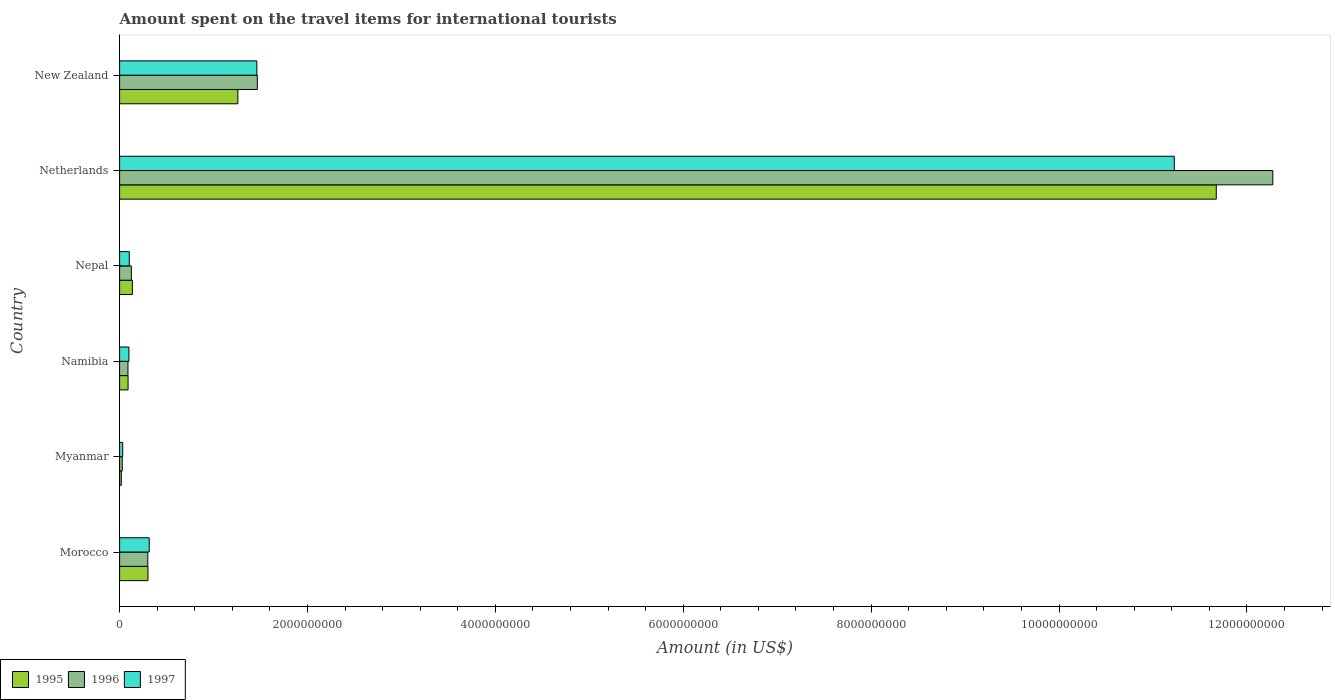How many groups of bars are there?
Provide a short and direct response. 6. Are the number of bars on each tick of the Y-axis equal?
Offer a very short reply. Yes. How many bars are there on the 5th tick from the top?
Your response must be concise. 3. What is the label of the 2nd group of bars from the top?
Ensure brevity in your answer.  Netherlands. In how many cases, is the number of bars for a given country not equal to the number of legend labels?
Ensure brevity in your answer.  0. What is the amount spent on the travel items for international tourists in 1995 in Namibia?
Make the answer very short. 9.00e+07. Across all countries, what is the maximum amount spent on the travel items for international tourists in 1996?
Provide a short and direct response. 1.23e+1. Across all countries, what is the minimum amount spent on the travel items for international tourists in 1997?
Offer a terse response. 3.30e+07. In which country was the amount spent on the travel items for international tourists in 1996 maximum?
Ensure brevity in your answer.  Netherlands. In which country was the amount spent on the travel items for international tourists in 1996 minimum?
Your answer should be very brief. Myanmar. What is the total amount spent on the travel items for international tourists in 1996 in the graph?
Keep it short and to the point. 1.43e+1. What is the difference between the amount spent on the travel items for international tourists in 1996 in Myanmar and that in Nepal?
Provide a succinct answer. -9.70e+07. What is the difference between the amount spent on the travel items for international tourists in 1995 in Myanmar and the amount spent on the travel items for international tourists in 1996 in Morocco?
Keep it short and to the point. -2.82e+08. What is the average amount spent on the travel items for international tourists in 1997 per country?
Provide a short and direct response. 2.21e+09. What is the difference between the amount spent on the travel items for international tourists in 1996 and amount spent on the travel items for international tourists in 1997 in Nepal?
Offer a very short reply. 2.20e+07. In how many countries, is the amount spent on the travel items for international tourists in 1996 greater than 6000000000 US$?
Keep it short and to the point. 1. What is the ratio of the amount spent on the travel items for international tourists in 1996 in Nepal to that in Netherlands?
Your answer should be compact. 0.01. Is the amount spent on the travel items for international tourists in 1995 in Morocco less than that in New Zealand?
Offer a very short reply. Yes. Is the difference between the amount spent on the travel items for international tourists in 1996 in Morocco and Netherlands greater than the difference between the amount spent on the travel items for international tourists in 1997 in Morocco and Netherlands?
Provide a short and direct response. No. What is the difference between the highest and the second highest amount spent on the travel items for international tourists in 1995?
Offer a terse response. 1.04e+1. What is the difference between the highest and the lowest amount spent on the travel items for international tourists in 1996?
Provide a succinct answer. 1.22e+1. Is the sum of the amount spent on the travel items for international tourists in 1995 in Morocco and Nepal greater than the maximum amount spent on the travel items for international tourists in 1996 across all countries?
Your answer should be very brief. No. What does the 2nd bar from the bottom in Netherlands represents?
Your answer should be compact. 1996. Is it the case that in every country, the sum of the amount spent on the travel items for international tourists in 1995 and amount spent on the travel items for international tourists in 1997 is greater than the amount spent on the travel items for international tourists in 1996?
Keep it short and to the point. Yes. How many bars are there?
Offer a very short reply. 18. What is the difference between two consecutive major ticks on the X-axis?
Make the answer very short. 2.00e+09. Are the values on the major ticks of X-axis written in scientific E-notation?
Provide a short and direct response. No. Does the graph contain any zero values?
Your response must be concise. No. How are the legend labels stacked?
Provide a short and direct response. Horizontal. What is the title of the graph?
Make the answer very short. Amount spent on the travel items for international tourists. Does "1982" appear as one of the legend labels in the graph?
Provide a succinct answer. No. What is the label or title of the X-axis?
Provide a short and direct response. Amount (in US$). What is the Amount (in US$) of 1995 in Morocco?
Your answer should be very brief. 3.02e+08. What is the Amount (in US$) of 1996 in Morocco?
Keep it short and to the point. 3.00e+08. What is the Amount (in US$) of 1997 in Morocco?
Make the answer very short. 3.15e+08. What is the Amount (in US$) in 1995 in Myanmar?
Ensure brevity in your answer.  1.80e+07. What is the Amount (in US$) of 1996 in Myanmar?
Your answer should be very brief. 2.80e+07. What is the Amount (in US$) of 1997 in Myanmar?
Your answer should be very brief. 3.30e+07. What is the Amount (in US$) of 1995 in Namibia?
Offer a terse response. 9.00e+07. What is the Amount (in US$) in 1996 in Namibia?
Offer a terse response. 8.90e+07. What is the Amount (in US$) in 1997 in Namibia?
Make the answer very short. 9.90e+07. What is the Amount (in US$) of 1995 in Nepal?
Your answer should be very brief. 1.36e+08. What is the Amount (in US$) in 1996 in Nepal?
Keep it short and to the point. 1.25e+08. What is the Amount (in US$) of 1997 in Nepal?
Provide a short and direct response. 1.03e+08. What is the Amount (in US$) in 1995 in Netherlands?
Offer a terse response. 1.17e+1. What is the Amount (in US$) in 1996 in Netherlands?
Offer a very short reply. 1.23e+1. What is the Amount (in US$) of 1997 in Netherlands?
Your response must be concise. 1.12e+1. What is the Amount (in US$) of 1995 in New Zealand?
Provide a short and direct response. 1.26e+09. What is the Amount (in US$) of 1996 in New Zealand?
Give a very brief answer. 1.47e+09. What is the Amount (in US$) of 1997 in New Zealand?
Keep it short and to the point. 1.46e+09. Across all countries, what is the maximum Amount (in US$) in 1995?
Your answer should be very brief. 1.17e+1. Across all countries, what is the maximum Amount (in US$) in 1996?
Your answer should be very brief. 1.23e+1. Across all countries, what is the maximum Amount (in US$) of 1997?
Provide a short and direct response. 1.12e+1. Across all countries, what is the minimum Amount (in US$) of 1995?
Your response must be concise. 1.80e+07. Across all countries, what is the minimum Amount (in US$) in 1996?
Keep it short and to the point. 2.80e+07. Across all countries, what is the minimum Amount (in US$) of 1997?
Your answer should be compact. 3.30e+07. What is the total Amount (in US$) in 1995 in the graph?
Provide a short and direct response. 1.35e+1. What is the total Amount (in US$) in 1996 in the graph?
Offer a very short reply. 1.43e+1. What is the total Amount (in US$) in 1997 in the graph?
Make the answer very short. 1.32e+1. What is the difference between the Amount (in US$) of 1995 in Morocco and that in Myanmar?
Provide a short and direct response. 2.84e+08. What is the difference between the Amount (in US$) in 1996 in Morocco and that in Myanmar?
Your response must be concise. 2.72e+08. What is the difference between the Amount (in US$) in 1997 in Morocco and that in Myanmar?
Give a very brief answer. 2.82e+08. What is the difference between the Amount (in US$) in 1995 in Morocco and that in Namibia?
Provide a succinct answer. 2.12e+08. What is the difference between the Amount (in US$) of 1996 in Morocco and that in Namibia?
Provide a succinct answer. 2.11e+08. What is the difference between the Amount (in US$) of 1997 in Morocco and that in Namibia?
Offer a very short reply. 2.16e+08. What is the difference between the Amount (in US$) in 1995 in Morocco and that in Nepal?
Your response must be concise. 1.66e+08. What is the difference between the Amount (in US$) in 1996 in Morocco and that in Nepal?
Provide a succinct answer. 1.75e+08. What is the difference between the Amount (in US$) of 1997 in Morocco and that in Nepal?
Provide a short and direct response. 2.12e+08. What is the difference between the Amount (in US$) in 1995 in Morocco and that in Netherlands?
Ensure brevity in your answer.  -1.14e+1. What is the difference between the Amount (in US$) of 1996 in Morocco and that in Netherlands?
Make the answer very short. -1.20e+1. What is the difference between the Amount (in US$) in 1997 in Morocco and that in Netherlands?
Your answer should be very brief. -1.09e+1. What is the difference between the Amount (in US$) in 1995 in Morocco and that in New Zealand?
Your response must be concise. -9.57e+08. What is the difference between the Amount (in US$) of 1996 in Morocco and that in New Zealand?
Your answer should be very brief. -1.17e+09. What is the difference between the Amount (in US$) of 1997 in Morocco and that in New Zealand?
Offer a terse response. -1.15e+09. What is the difference between the Amount (in US$) in 1995 in Myanmar and that in Namibia?
Your response must be concise. -7.20e+07. What is the difference between the Amount (in US$) of 1996 in Myanmar and that in Namibia?
Your answer should be very brief. -6.10e+07. What is the difference between the Amount (in US$) in 1997 in Myanmar and that in Namibia?
Offer a very short reply. -6.60e+07. What is the difference between the Amount (in US$) in 1995 in Myanmar and that in Nepal?
Your answer should be compact. -1.18e+08. What is the difference between the Amount (in US$) in 1996 in Myanmar and that in Nepal?
Offer a terse response. -9.70e+07. What is the difference between the Amount (in US$) of 1997 in Myanmar and that in Nepal?
Provide a succinct answer. -7.00e+07. What is the difference between the Amount (in US$) of 1995 in Myanmar and that in Netherlands?
Provide a short and direct response. -1.17e+1. What is the difference between the Amount (in US$) of 1996 in Myanmar and that in Netherlands?
Provide a succinct answer. -1.22e+1. What is the difference between the Amount (in US$) of 1997 in Myanmar and that in Netherlands?
Offer a very short reply. -1.12e+1. What is the difference between the Amount (in US$) of 1995 in Myanmar and that in New Zealand?
Make the answer very short. -1.24e+09. What is the difference between the Amount (in US$) of 1996 in Myanmar and that in New Zealand?
Provide a succinct answer. -1.44e+09. What is the difference between the Amount (in US$) in 1997 in Myanmar and that in New Zealand?
Make the answer very short. -1.43e+09. What is the difference between the Amount (in US$) of 1995 in Namibia and that in Nepal?
Ensure brevity in your answer.  -4.60e+07. What is the difference between the Amount (in US$) in 1996 in Namibia and that in Nepal?
Keep it short and to the point. -3.60e+07. What is the difference between the Amount (in US$) in 1997 in Namibia and that in Nepal?
Ensure brevity in your answer.  -4.00e+06. What is the difference between the Amount (in US$) of 1995 in Namibia and that in Netherlands?
Offer a very short reply. -1.16e+1. What is the difference between the Amount (in US$) in 1996 in Namibia and that in Netherlands?
Provide a short and direct response. -1.22e+1. What is the difference between the Amount (in US$) of 1997 in Namibia and that in Netherlands?
Provide a short and direct response. -1.11e+1. What is the difference between the Amount (in US$) of 1995 in Namibia and that in New Zealand?
Your answer should be very brief. -1.17e+09. What is the difference between the Amount (in US$) in 1996 in Namibia and that in New Zealand?
Give a very brief answer. -1.38e+09. What is the difference between the Amount (in US$) in 1997 in Namibia and that in New Zealand?
Provide a short and direct response. -1.36e+09. What is the difference between the Amount (in US$) of 1995 in Nepal and that in Netherlands?
Your response must be concise. -1.15e+1. What is the difference between the Amount (in US$) of 1996 in Nepal and that in Netherlands?
Keep it short and to the point. -1.22e+1. What is the difference between the Amount (in US$) in 1997 in Nepal and that in Netherlands?
Your answer should be very brief. -1.11e+1. What is the difference between the Amount (in US$) of 1995 in Nepal and that in New Zealand?
Offer a terse response. -1.12e+09. What is the difference between the Amount (in US$) in 1996 in Nepal and that in New Zealand?
Provide a succinct answer. -1.34e+09. What is the difference between the Amount (in US$) of 1997 in Nepal and that in New Zealand?
Provide a short and direct response. -1.36e+09. What is the difference between the Amount (in US$) of 1995 in Netherlands and that in New Zealand?
Ensure brevity in your answer.  1.04e+1. What is the difference between the Amount (in US$) of 1996 in Netherlands and that in New Zealand?
Make the answer very short. 1.08e+1. What is the difference between the Amount (in US$) of 1997 in Netherlands and that in New Zealand?
Your response must be concise. 9.77e+09. What is the difference between the Amount (in US$) of 1995 in Morocco and the Amount (in US$) of 1996 in Myanmar?
Keep it short and to the point. 2.74e+08. What is the difference between the Amount (in US$) of 1995 in Morocco and the Amount (in US$) of 1997 in Myanmar?
Keep it short and to the point. 2.69e+08. What is the difference between the Amount (in US$) of 1996 in Morocco and the Amount (in US$) of 1997 in Myanmar?
Keep it short and to the point. 2.67e+08. What is the difference between the Amount (in US$) in 1995 in Morocco and the Amount (in US$) in 1996 in Namibia?
Your response must be concise. 2.13e+08. What is the difference between the Amount (in US$) of 1995 in Morocco and the Amount (in US$) of 1997 in Namibia?
Your response must be concise. 2.03e+08. What is the difference between the Amount (in US$) in 1996 in Morocco and the Amount (in US$) in 1997 in Namibia?
Offer a very short reply. 2.01e+08. What is the difference between the Amount (in US$) of 1995 in Morocco and the Amount (in US$) of 1996 in Nepal?
Provide a short and direct response. 1.77e+08. What is the difference between the Amount (in US$) of 1995 in Morocco and the Amount (in US$) of 1997 in Nepal?
Provide a short and direct response. 1.99e+08. What is the difference between the Amount (in US$) in 1996 in Morocco and the Amount (in US$) in 1997 in Nepal?
Make the answer very short. 1.97e+08. What is the difference between the Amount (in US$) of 1995 in Morocco and the Amount (in US$) of 1996 in Netherlands?
Offer a terse response. -1.20e+1. What is the difference between the Amount (in US$) in 1995 in Morocco and the Amount (in US$) in 1997 in Netherlands?
Keep it short and to the point. -1.09e+1. What is the difference between the Amount (in US$) of 1996 in Morocco and the Amount (in US$) of 1997 in Netherlands?
Give a very brief answer. -1.09e+1. What is the difference between the Amount (in US$) of 1995 in Morocco and the Amount (in US$) of 1996 in New Zealand?
Ensure brevity in your answer.  -1.16e+09. What is the difference between the Amount (in US$) of 1995 in Morocco and the Amount (in US$) of 1997 in New Zealand?
Provide a succinct answer. -1.16e+09. What is the difference between the Amount (in US$) in 1996 in Morocco and the Amount (in US$) in 1997 in New Zealand?
Ensure brevity in your answer.  -1.16e+09. What is the difference between the Amount (in US$) in 1995 in Myanmar and the Amount (in US$) in 1996 in Namibia?
Offer a terse response. -7.10e+07. What is the difference between the Amount (in US$) of 1995 in Myanmar and the Amount (in US$) of 1997 in Namibia?
Offer a terse response. -8.10e+07. What is the difference between the Amount (in US$) of 1996 in Myanmar and the Amount (in US$) of 1997 in Namibia?
Offer a terse response. -7.10e+07. What is the difference between the Amount (in US$) of 1995 in Myanmar and the Amount (in US$) of 1996 in Nepal?
Offer a terse response. -1.07e+08. What is the difference between the Amount (in US$) in 1995 in Myanmar and the Amount (in US$) in 1997 in Nepal?
Make the answer very short. -8.50e+07. What is the difference between the Amount (in US$) of 1996 in Myanmar and the Amount (in US$) of 1997 in Nepal?
Your answer should be very brief. -7.50e+07. What is the difference between the Amount (in US$) of 1995 in Myanmar and the Amount (in US$) of 1996 in Netherlands?
Ensure brevity in your answer.  -1.23e+1. What is the difference between the Amount (in US$) of 1995 in Myanmar and the Amount (in US$) of 1997 in Netherlands?
Provide a succinct answer. -1.12e+1. What is the difference between the Amount (in US$) in 1996 in Myanmar and the Amount (in US$) in 1997 in Netherlands?
Your answer should be very brief. -1.12e+1. What is the difference between the Amount (in US$) of 1995 in Myanmar and the Amount (in US$) of 1996 in New Zealand?
Keep it short and to the point. -1.45e+09. What is the difference between the Amount (in US$) in 1995 in Myanmar and the Amount (in US$) in 1997 in New Zealand?
Your answer should be compact. -1.44e+09. What is the difference between the Amount (in US$) of 1996 in Myanmar and the Amount (in US$) of 1997 in New Zealand?
Your answer should be compact. -1.43e+09. What is the difference between the Amount (in US$) in 1995 in Namibia and the Amount (in US$) in 1996 in Nepal?
Your answer should be compact. -3.50e+07. What is the difference between the Amount (in US$) of 1995 in Namibia and the Amount (in US$) of 1997 in Nepal?
Keep it short and to the point. -1.30e+07. What is the difference between the Amount (in US$) of 1996 in Namibia and the Amount (in US$) of 1997 in Nepal?
Provide a short and direct response. -1.40e+07. What is the difference between the Amount (in US$) of 1995 in Namibia and the Amount (in US$) of 1996 in Netherlands?
Keep it short and to the point. -1.22e+1. What is the difference between the Amount (in US$) of 1995 in Namibia and the Amount (in US$) of 1997 in Netherlands?
Ensure brevity in your answer.  -1.11e+1. What is the difference between the Amount (in US$) in 1996 in Namibia and the Amount (in US$) in 1997 in Netherlands?
Provide a short and direct response. -1.11e+1. What is the difference between the Amount (in US$) of 1995 in Namibia and the Amount (in US$) of 1996 in New Zealand?
Give a very brief answer. -1.38e+09. What is the difference between the Amount (in US$) in 1995 in Namibia and the Amount (in US$) in 1997 in New Zealand?
Provide a succinct answer. -1.37e+09. What is the difference between the Amount (in US$) of 1996 in Namibia and the Amount (in US$) of 1997 in New Zealand?
Make the answer very short. -1.37e+09. What is the difference between the Amount (in US$) in 1995 in Nepal and the Amount (in US$) in 1996 in Netherlands?
Your response must be concise. -1.21e+1. What is the difference between the Amount (in US$) of 1995 in Nepal and the Amount (in US$) of 1997 in Netherlands?
Your response must be concise. -1.11e+1. What is the difference between the Amount (in US$) of 1996 in Nepal and the Amount (in US$) of 1997 in Netherlands?
Give a very brief answer. -1.11e+1. What is the difference between the Amount (in US$) in 1995 in Nepal and the Amount (in US$) in 1996 in New Zealand?
Offer a terse response. -1.33e+09. What is the difference between the Amount (in US$) of 1995 in Nepal and the Amount (in US$) of 1997 in New Zealand?
Offer a terse response. -1.32e+09. What is the difference between the Amount (in US$) in 1996 in Nepal and the Amount (in US$) in 1997 in New Zealand?
Provide a short and direct response. -1.34e+09. What is the difference between the Amount (in US$) in 1995 in Netherlands and the Amount (in US$) in 1996 in New Zealand?
Provide a short and direct response. 1.02e+1. What is the difference between the Amount (in US$) in 1995 in Netherlands and the Amount (in US$) in 1997 in New Zealand?
Keep it short and to the point. 1.02e+1. What is the difference between the Amount (in US$) of 1996 in Netherlands and the Amount (in US$) of 1997 in New Zealand?
Provide a short and direct response. 1.08e+1. What is the average Amount (in US$) in 1995 per country?
Offer a terse response. 2.25e+09. What is the average Amount (in US$) in 1996 per country?
Your answer should be compact. 2.38e+09. What is the average Amount (in US$) in 1997 per country?
Ensure brevity in your answer.  2.21e+09. What is the difference between the Amount (in US$) of 1995 and Amount (in US$) of 1997 in Morocco?
Give a very brief answer. -1.30e+07. What is the difference between the Amount (in US$) in 1996 and Amount (in US$) in 1997 in Morocco?
Keep it short and to the point. -1.50e+07. What is the difference between the Amount (in US$) of 1995 and Amount (in US$) of 1996 in Myanmar?
Make the answer very short. -1.00e+07. What is the difference between the Amount (in US$) of 1995 and Amount (in US$) of 1997 in Myanmar?
Offer a terse response. -1.50e+07. What is the difference between the Amount (in US$) of 1996 and Amount (in US$) of 1997 in Myanmar?
Ensure brevity in your answer.  -5.00e+06. What is the difference between the Amount (in US$) in 1995 and Amount (in US$) in 1996 in Namibia?
Your answer should be very brief. 1.00e+06. What is the difference between the Amount (in US$) in 1995 and Amount (in US$) in 1997 in Namibia?
Make the answer very short. -9.00e+06. What is the difference between the Amount (in US$) of 1996 and Amount (in US$) of 1997 in Namibia?
Give a very brief answer. -1.00e+07. What is the difference between the Amount (in US$) in 1995 and Amount (in US$) in 1996 in Nepal?
Your answer should be very brief. 1.10e+07. What is the difference between the Amount (in US$) of 1995 and Amount (in US$) of 1997 in Nepal?
Provide a short and direct response. 3.30e+07. What is the difference between the Amount (in US$) in 1996 and Amount (in US$) in 1997 in Nepal?
Keep it short and to the point. 2.20e+07. What is the difference between the Amount (in US$) in 1995 and Amount (in US$) in 1996 in Netherlands?
Your answer should be compact. -6.02e+08. What is the difference between the Amount (in US$) of 1995 and Amount (in US$) of 1997 in Netherlands?
Your answer should be compact. 4.47e+08. What is the difference between the Amount (in US$) of 1996 and Amount (in US$) of 1997 in Netherlands?
Your answer should be very brief. 1.05e+09. What is the difference between the Amount (in US$) in 1995 and Amount (in US$) in 1996 in New Zealand?
Provide a succinct answer. -2.07e+08. What is the difference between the Amount (in US$) of 1995 and Amount (in US$) of 1997 in New Zealand?
Your answer should be very brief. -2.02e+08. What is the difference between the Amount (in US$) in 1996 and Amount (in US$) in 1997 in New Zealand?
Your answer should be very brief. 5.00e+06. What is the ratio of the Amount (in US$) in 1995 in Morocco to that in Myanmar?
Provide a short and direct response. 16.78. What is the ratio of the Amount (in US$) in 1996 in Morocco to that in Myanmar?
Make the answer very short. 10.71. What is the ratio of the Amount (in US$) in 1997 in Morocco to that in Myanmar?
Keep it short and to the point. 9.55. What is the ratio of the Amount (in US$) of 1995 in Morocco to that in Namibia?
Your response must be concise. 3.36. What is the ratio of the Amount (in US$) of 1996 in Morocco to that in Namibia?
Offer a very short reply. 3.37. What is the ratio of the Amount (in US$) of 1997 in Morocco to that in Namibia?
Keep it short and to the point. 3.18. What is the ratio of the Amount (in US$) of 1995 in Morocco to that in Nepal?
Offer a very short reply. 2.22. What is the ratio of the Amount (in US$) of 1997 in Morocco to that in Nepal?
Keep it short and to the point. 3.06. What is the ratio of the Amount (in US$) in 1995 in Morocco to that in Netherlands?
Offer a very short reply. 0.03. What is the ratio of the Amount (in US$) of 1996 in Morocco to that in Netherlands?
Provide a succinct answer. 0.02. What is the ratio of the Amount (in US$) in 1997 in Morocco to that in Netherlands?
Your response must be concise. 0.03. What is the ratio of the Amount (in US$) of 1995 in Morocco to that in New Zealand?
Offer a terse response. 0.24. What is the ratio of the Amount (in US$) of 1996 in Morocco to that in New Zealand?
Give a very brief answer. 0.2. What is the ratio of the Amount (in US$) of 1997 in Morocco to that in New Zealand?
Provide a short and direct response. 0.22. What is the ratio of the Amount (in US$) in 1996 in Myanmar to that in Namibia?
Make the answer very short. 0.31. What is the ratio of the Amount (in US$) in 1995 in Myanmar to that in Nepal?
Ensure brevity in your answer.  0.13. What is the ratio of the Amount (in US$) in 1996 in Myanmar to that in Nepal?
Your answer should be compact. 0.22. What is the ratio of the Amount (in US$) in 1997 in Myanmar to that in Nepal?
Ensure brevity in your answer.  0.32. What is the ratio of the Amount (in US$) in 1995 in Myanmar to that in Netherlands?
Your response must be concise. 0. What is the ratio of the Amount (in US$) of 1996 in Myanmar to that in Netherlands?
Make the answer very short. 0. What is the ratio of the Amount (in US$) of 1997 in Myanmar to that in Netherlands?
Your answer should be compact. 0. What is the ratio of the Amount (in US$) of 1995 in Myanmar to that in New Zealand?
Make the answer very short. 0.01. What is the ratio of the Amount (in US$) of 1996 in Myanmar to that in New Zealand?
Your answer should be compact. 0.02. What is the ratio of the Amount (in US$) in 1997 in Myanmar to that in New Zealand?
Your answer should be very brief. 0.02. What is the ratio of the Amount (in US$) of 1995 in Namibia to that in Nepal?
Provide a succinct answer. 0.66. What is the ratio of the Amount (in US$) in 1996 in Namibia to that in Nepal?
Ensure brevity in your answer.  0.71. What is the ratio of the Amount (in US$) in 1997 in Namibia to that in Nepal?
Give a very brief answer. 0.96. What is the ratio of the Amount (in US$) in 1995 in Namibia to that in Netherlands?
Provide a succinct answer. 0.01. What is the ratio of the Amount (in US$) of 1996 in Namibia to that in Netherlands?
Make the answer very short. 0.01. What is the ratio of the Amount (in US$) of 1997 in Namibia to that in Netherlands?
Offer a terse response. 0.01. What is the ratio of the Amount (in US$) of 1995 in Namibia to that in New Zealand?
Provide a short and direct response. 0.07. What is the ratio of the Amount (in US$) of 1996 in Namibia to that in New Zealand?
Your answer should be compact. 0.06. What is the ratio of the Amount (in US$) in 1997 in Namibia to that in New Zealand?
Your answer should be compact. 0.07. What is the ratio of the Amount (in US$) of 1995 in Nepal to that in Netherlands?
Give a very brief answer. 0.01. What is the ratio of the Amount (in US$) in 1996 in Nepal to that in Netherlands?
Provide a short and direct response. 0.01. What is the ratio of the Amount (in US$) in 1997 in Nepal to that in Netherlands?
Provide a short and direct response. 0.01. What is the ratio of the Amount (in US$) in 1995 in Nepal to that in New Zealand?
Keep it short and to the point. 0.11. What is the ratio of the Amount (in US$) in 1996 in Nepal to that in New Zealand?
Make the answer very short. 0.09. What is the ratio of the Amount (in US$) in 1997 in Nepal to that in New Zealand?
Offer a very short reply. 0.07. What is the ratio of the Amount (in US$) in 1995 in Netherlands to that in New Zealand?
Your answer should be very brief. 9.27. What is the ratio of the Amount (in US$) in 1996 in Netherlands to that in New Zealand?
Ensure brevity in your answer.  8.37. What is the ratio of the Amount (in US$) of 1997 in Netherlands to that in New Zealand?
Provide a short and direct response. 7.68. What is the difference between the highest and the second highest Amount (in US$) in 1995?
Give a very brief answer. 1.04e+1. What is the difference between the highest and the second highest Amount (in US$) of 1996?
Offer a very short reply. 1.08e+1. What is the difference between the highest and the second highest Amount (in US$) in 1997?
Your response must be concise. 9.77e+09. What is the difference between the highest and the lowest Amount (in US$) in 1995?
Your answer should be compact. 1.17e+1. What is the difference between the highest and the lowest Amount (in US$) in 1996?
Make the answer very short. 1.22e+1. What is the difference between the highest and the lowest Amount (in US$) of 1997?
Your answer should be compact. 1.12e+1. 